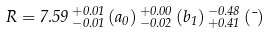<formula> <loc_0><loc_0><loc_500><loc_500>R = 7 . 5 9 \, ^ { + 0 . 0 1 } _ { - 0 . 0 1 } \, ( a _ { 0 } ) \, ^ { + 0 . 0 0 } _ { - 0 . 0 2 } \, ( b _ { 1 } ) \, ^ { - 0 . 4 8 } _ { + 0 . 4 1 } \, ( \mu )</formula> 